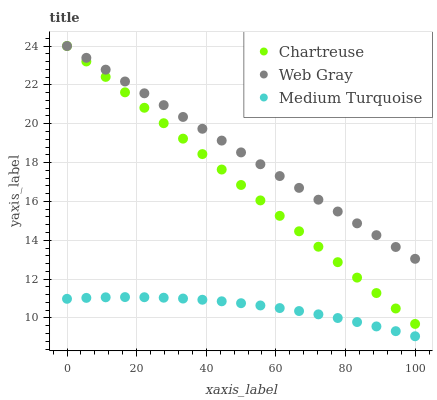Does Medium Turquoise have the minimum area under the curve?
Answer yes or no. Yes. Does Web Gray have the maximum area under the curve?
Answer yes or no. Yes. Does Web Gray have the minimum area under the curve?
Answer yes or no. No. Does Medium Turquoise have the maximum area under the curve?
Answer yes or no. No. Is Chartreuse the smoothest?
Answer yes or no. Yes. Is Medium Turquoise the roughest?
Answer yes or no. Yes. Is Web Gray the smoothest?
Answer yes or no. No. Is Web Gray the roughest?
Answer yes or no. No. Does Medium Turquoise have the lowest value?
Answer yes or no. Yes. Does Web Gray have the lowest value?
Answer yes or no. No. Does Web Gray have the highest value?
Answer yes or no. Yes. Does Medium Turquoise have the highest value?
Answer yes or no. No. Is Medium Turquoise less than Chartreuse?
Answer yes or no. Yes. Is Chartreuse greater than Medium Turquoise?
Answer yes or no. Yes. Does Web Gray intersect Chartreuse?
Answer yes or no. Yes. Is Web Gray less than Chartreuse?
Answer yes or no. No. Is Web Gray greater than Chartreuse?
Answer yes or no. No. Does Medium Turquoise intersect Chartreuse?
Answer yes or no. No. 